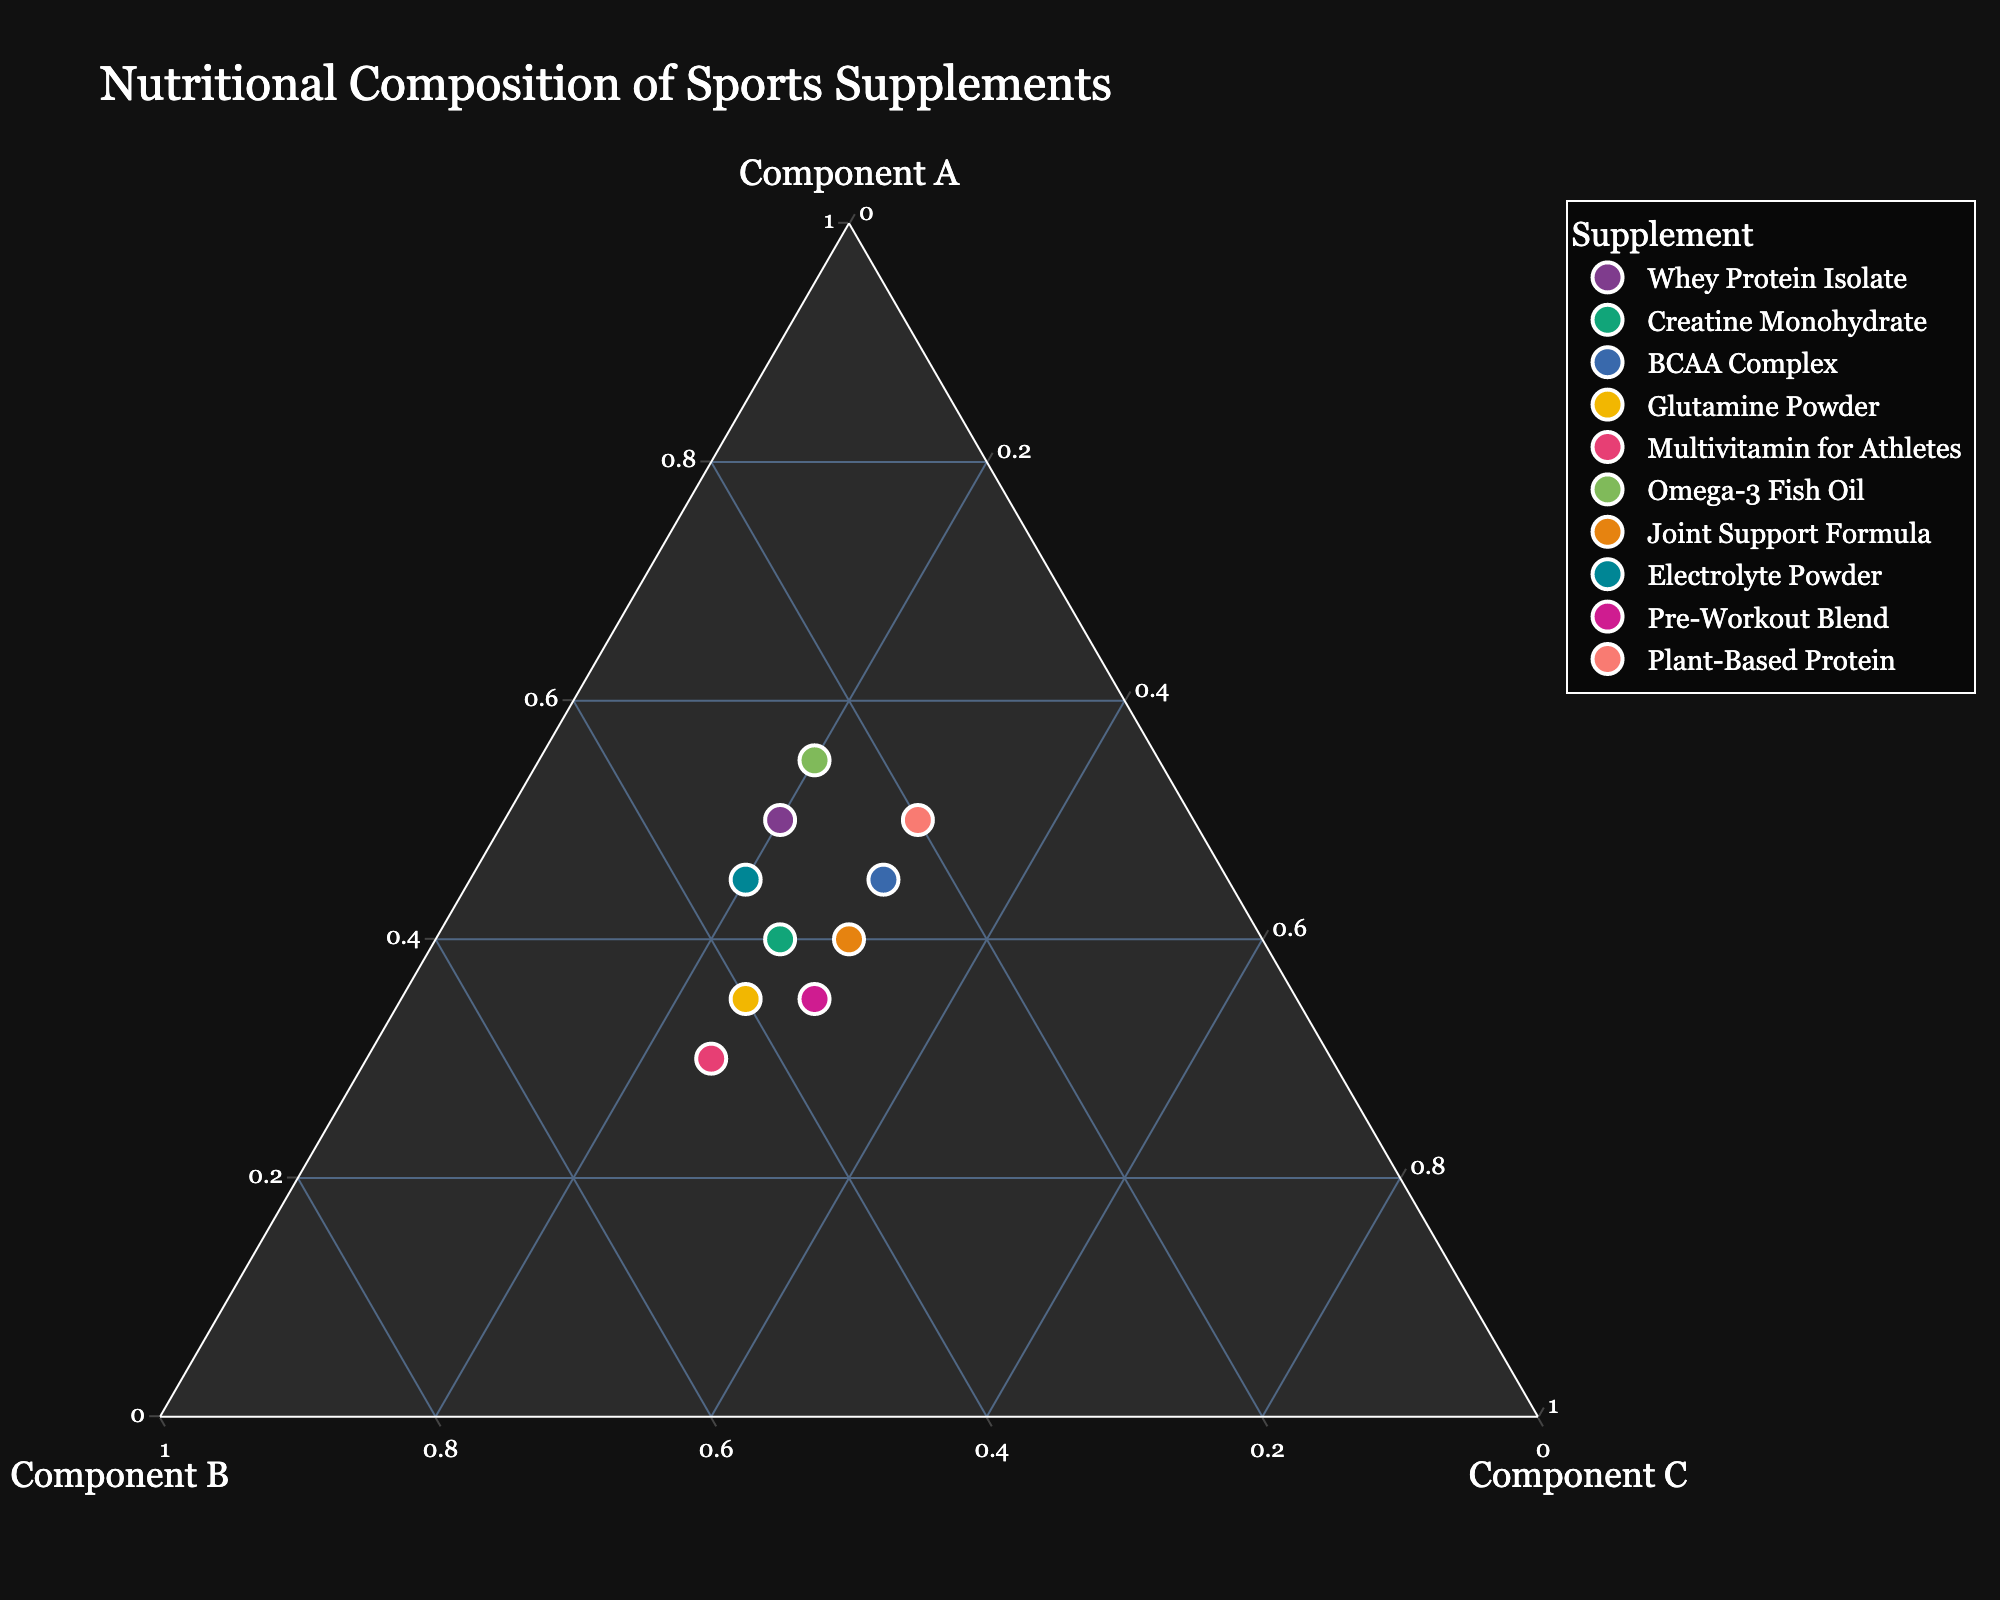What is the title of the chart? The title of the chart is displayed prominently at the top of the chart, usually in a larger font size to grab attention.
Answer: Nutritional Composition of Sports Supplements How many different sports supplements are displayed on the plot? Count the distinct data points (supplements) shown in the plot, each typically represented by a uniquely colored mark.
Answer: 10 Which supplement has the highest percentage of Component A? Look for the data point closest to the vertex labeled Component A, representing the highest concentration of Component A.
Answer: Omega-3 Fish Oil What is the percentage composition of Component B in Creatine Monohydrate? Identify the point labeled as Creatine Monohydrate and read the value along the axis representing Component B.
Answer: 35% Which two supplements have the same percentage of Component C, and what is that percentage? Compare the positions of the points along the axis representing Component C to find two points that lie at the same position, and read that value.
Answer: Whey Protein Isolate and Electrolyte Powder, 20% Which supplement has the most balanced composition? A balanced composition would be indicated by a point close to the center of the ternary plot, meaning all components are nearly equal.
Answer: Joint Support Formula Calculate the sum of Component A percentages for Whey Protein Isolate, Omega-3 Fish Oil, and Plant-Based Protein. Add the values for Component A for the specified supplements: 50 (Whey Protein Isolate) + 55 (Omega-3 Fish Oil) + 50 (Plant-Based Protein).
Answer: 155 Between Glutamine Powder and Multivitamin for Athletes, which supplement has a higher percentage of Component C, and what is the difference? Compare the values along the axis for Component C for both supplements and calculate their difference.
Answer: Multivitamin for Athletes; Difference is 25% - 25% = 0% What is the average percentage of Component B across all supplements? Sum all the percentages for Component B and divide by the total number of supplements (10). (30+35+25+40+45+25+30+35+35+20) / 10 = 320 / 10
Answer: 32% Among Whey Protein Isolate, Creatine Monohydrate, and BCAA Complex, which supplement has the lowest percentage of Component B? Compare the value of Component B for the three supplements and identify the lowest one.
Answer: Whey Protein Isolate 